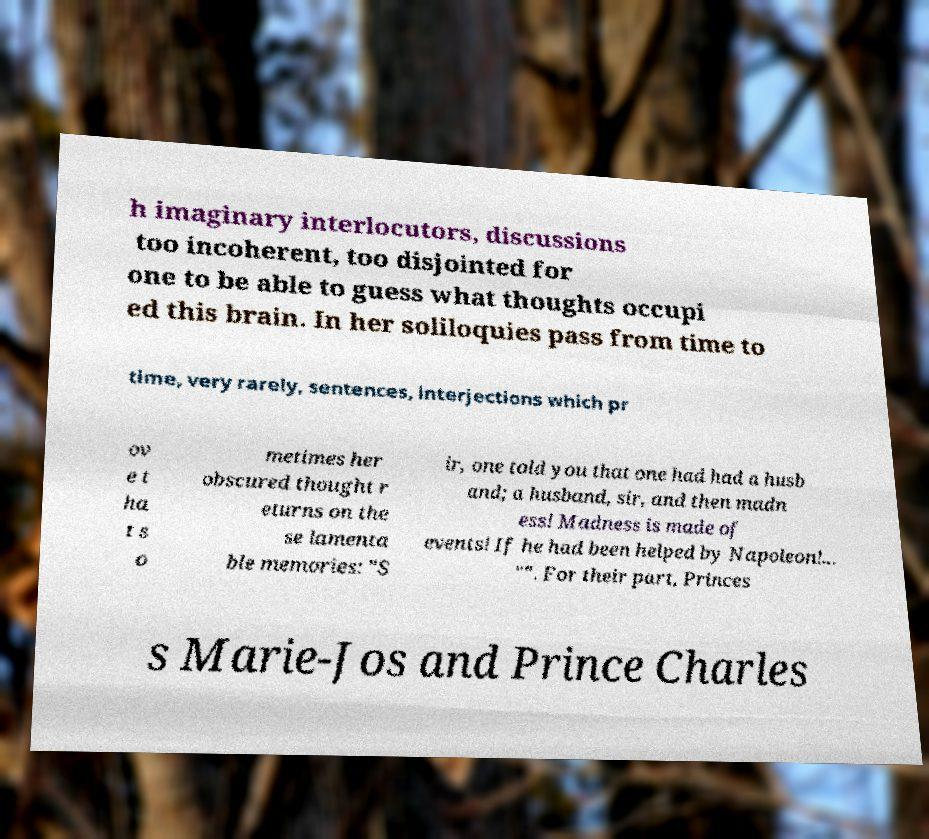Could you assist in decoding the text presented in this image and type it out clearly? h imaginary interlocutors, discussions too incoherent, too disjointed for one to be able to guess what thoughts occupi ed this brain. In her soliloquies pass from time to time, very rarely, sentences, interjections which pr ov e t ha t s o metimes her obscured thought r eturns on the se lamenta ble memories: "S ir, one told you that one had had a husb and; a husband, sir, and then madn ess! Madness is made of events! If he had been helped by Napoleon!... "". For their part, Princes s Marie-Jos and Prince Charles 